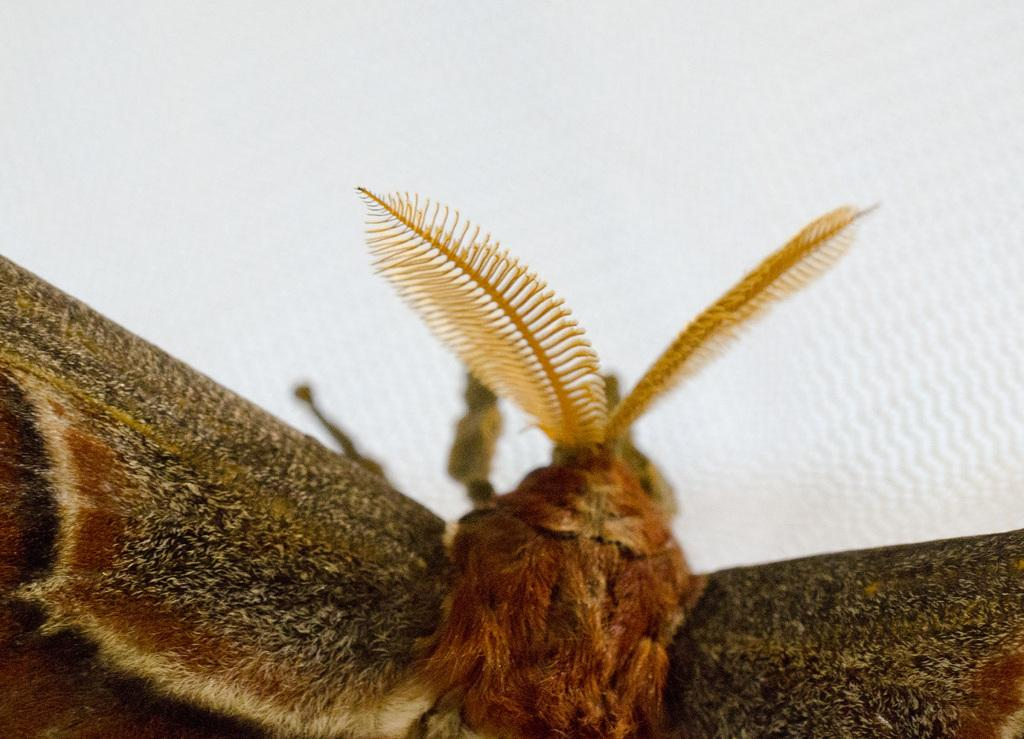What is present in the image that has wings? There is a fly in the image that has wings. What is the color of the paper in the image? The paper in the image is white. How does the giraffe interact with the dirt in the image? There is no giraffe present in the image, so it cannot interact with any dirt. 